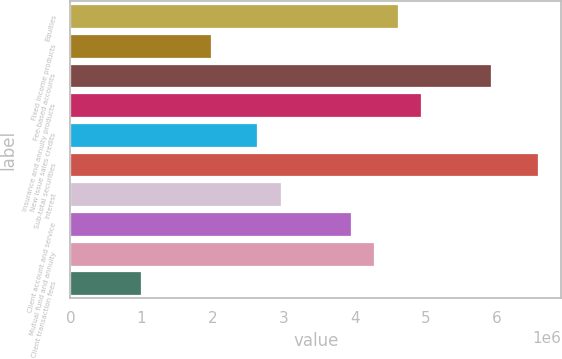<chart> <loc_0><loc_0><loc_500><loc_500><bar_chart><fcel>Equities<fcel>Fixed income products<fcel>Fee-based accounts<fcel>Insurance and annuity products<fcel>New issue sales credits<fcel>Sub-total securities<fcel>Interest<fcel>Client account and service<fcel>Mutual fund and annuity<fcel>Client transaction fees<nl><fcel>4.60519e+06<fcel>1.97382e+06<fcel>5.92087e+06<fcel>4.93411e+06<fcel>2.63166e+06<fcel>6.57871e+06<fcel>2.96058e+06<fcel>3.94734e+06<fcel>4.27627e+06<fcel>987056<nl></chart> 